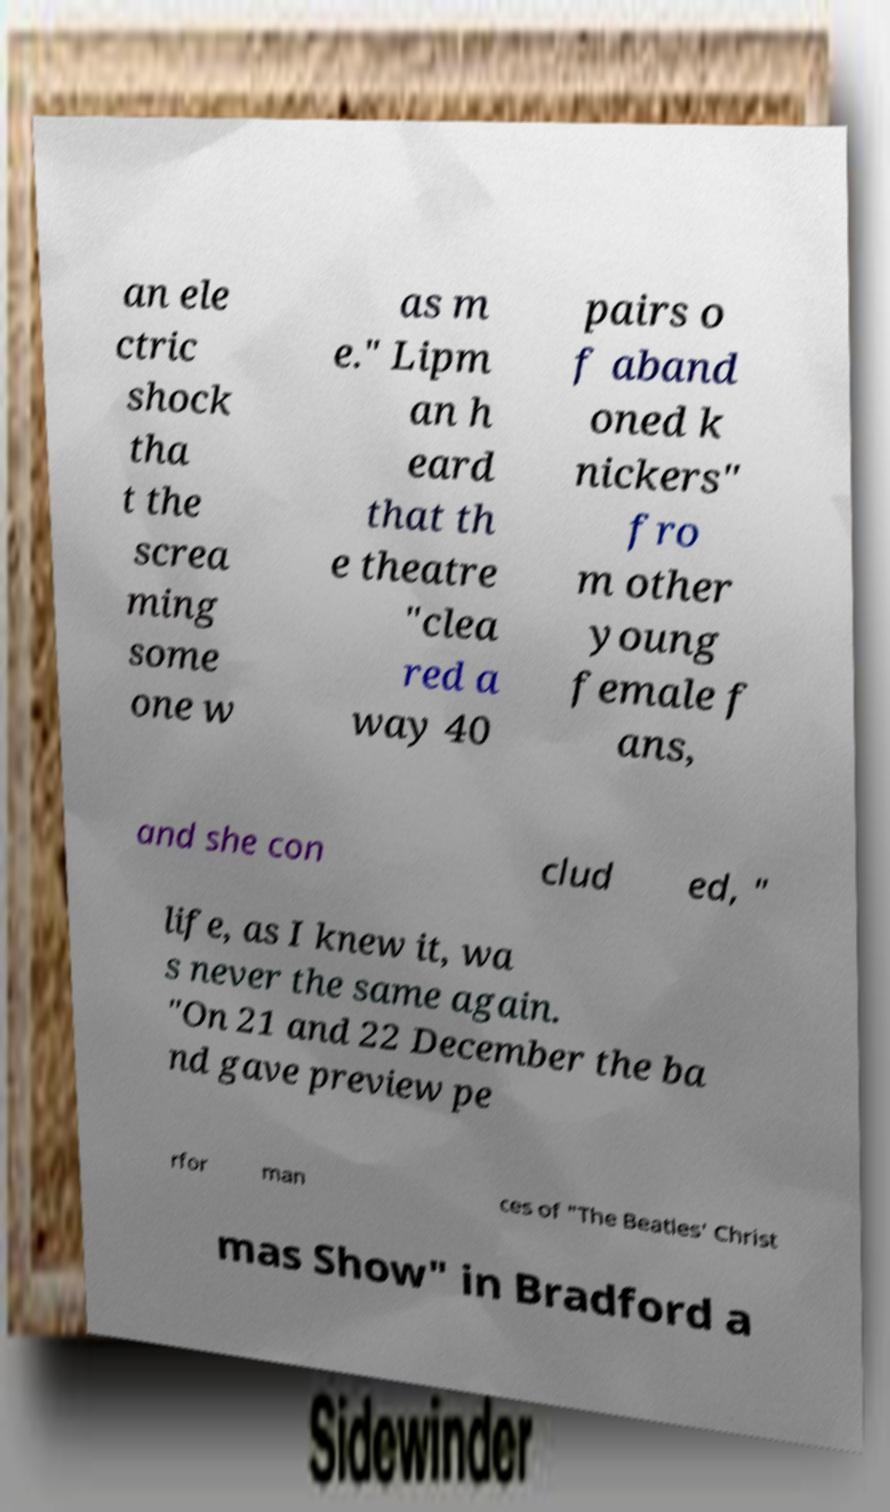Could you assist in decoding the text presented in this image and type it out clearly? an ele ctric shock tha t the screa ming some one w as m e." Lipm an h eard that th e theatre "clea red a way 40 pairs o f aband oned k nickers" fro m other young female f ans, and she con clud ed, " life, as I knew it, wa s never the same again. "On 21 and 22 December the ba nd gave preview pe rfor man ces of "The Beatles' Christ mas Show" in Bradford a 